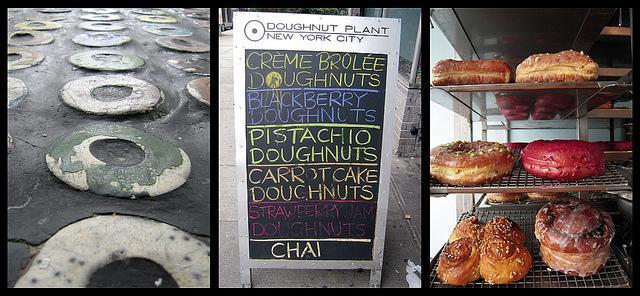How many separate pictures are in this image?
Give a very brief answer. 3. How many donuts are there?
Give a very brief answer. 5. 